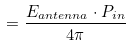<formula> <loc_0><loc_0><loc_500><loc_500>= \frac { E _ { a n t e n n a } \cdot P _ { i n } } { 4 \pi }</formula> 